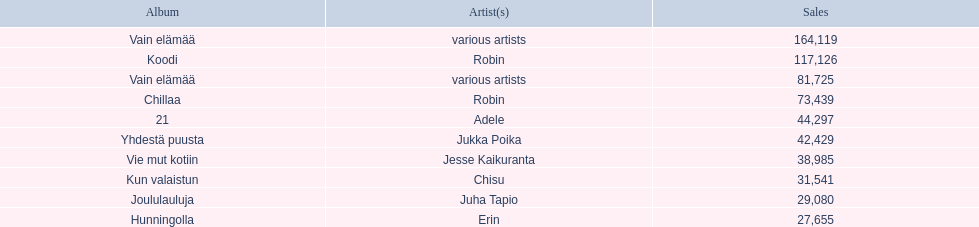What was the top selling album in this year? Vain elämää. 